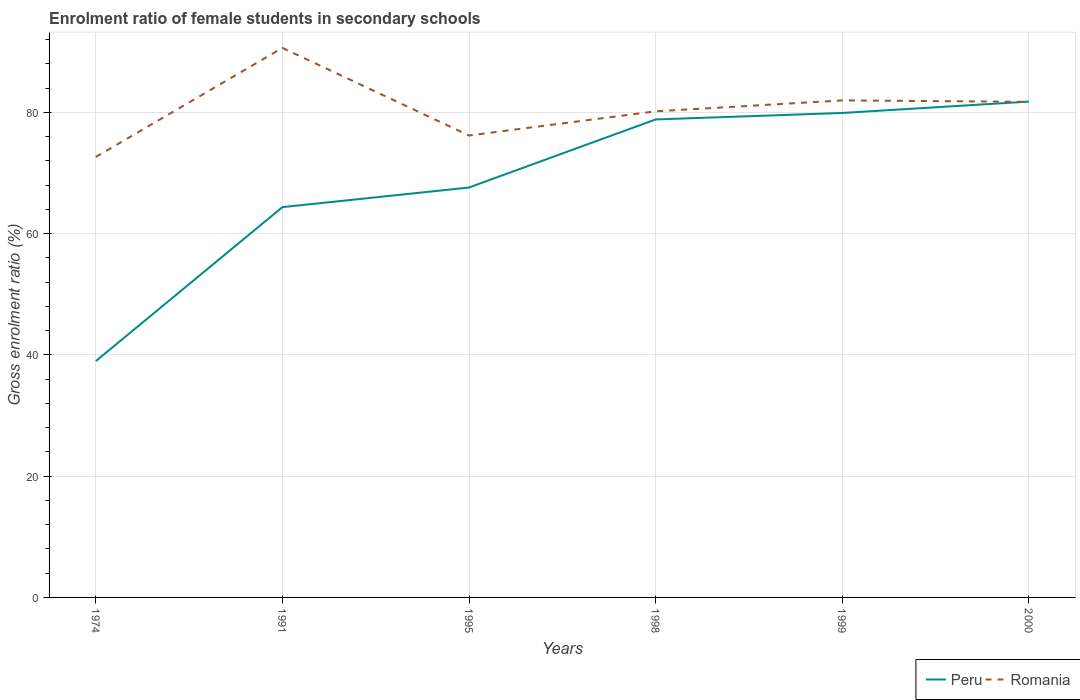How many different coloured lines are there?
Your response must be concise. 2. Is the number of lines equal to the number of legend labels?
Keep it short and to the point. Yes. Across all years, what is the maximum enrolment ratio of female students in secondary schools in Peru?
Give a very brief answer. 38.97. In which year was the enrolment ratio of female students in secondary schools in Romania maximum?
Give a very brief answer. 1974. What is the total enrolment ratio of female students in secondary schools in Peru in the graph?
Give a very brief answer. -1.87. What is the difference between the highest and the second highest enrolment ratio of female students in secondary schools in Romania?
Your answer should be compact. 17.98. Is the enrolment ratio of female students in secondary schools in Peru strictly greater than the enrolment ratio of female students in secondary schools in Romania over the years?
Ensure brevity in your answer.  No. How many years are there in the graph?
Give a very brief answer. 6. Does the graph contain any zero values?
Your answer should be very brief. No. Does the graph contain grids?
Provide a short and direct response. Yes. Where does the legend appear in the graph?
Provide a succinct answer. Bottom right. What is the title of the graph?
Provide a succinct answer. Enrolment ratio of female students in secondary schools. What is the Gross enrolment ratio (%) in Peru in 1974?
Keep it short and to the point. 38.97. What is the Gross enrolment ratio (%) of Romania in 1974?
Your answer should be very brief. 72.65. What is the Gross enrolment ratio (%) of Peru in 1991?
Your answer should be compact. 64.37. What is the Gross enrolment ratio (%) of Romania in 1991?
Your response must be concise. 90.63. What is the Gross enrolment ratio (%) in Peru in 1995?
Your answer should be very brief. 67.6. What is the Gross enrolment ratio (%) in Romania in 1995?
Your answer should be very brief. 76.18. What is the Gross enrolment ratio (%) in Peru in 1998?
Keep it short and to the point. 78.83. What is the Gross enrolment ratio (%) of Romania in 1998?
Your answer should be very brief. 80.17. What is the Gross enrolment ratio (%) in Peru in 1999?
Keep it short and to the point. 79.9. What is the Gross enrolment ratio (%) in Romania in 1999?
Provide a short and direct response. 81.97. What is the Gross enrolment ratio (%) of Peru in 2000?
Make the answer very short. 81.77. What is the Gross enrolment ratio (%) of Romania in 2000?
Your response must be concise. 81.74. Across all years, what is the maximum Gross enrolment ratio (%) of Peru?
Give a very brief answer. 81.77. Across all years, what is the maximum Gross enrolment ratio (%) of Romania?
Ensure brevity in your answer.  90.63. Across all years, what is the minimum Gross enrolment ratio (%) of Peru?
Your answer should be compact. 38.97. Across all years, what is the minimum Gross enrolment ratio (%) of Romania?
Your answer should be very brief. 72.65. What is the total Gross enrolment ratio (%) in Peru in the graph?
Ensure brevity in your answer.  411.43. What is the total Gross enrolment ratio (%) in Romania in the graph?
Keep it short and to the point. 483.33. What is the difference between the Gross enrolment ratio (%) in Peru in 1974 and that in 1991?
Keep it short and to the point. -25.4. What is the difference between the Gross enrolment ratio (%) of Romania in 1974 and that in 1991?
Provide a succinct answer. -17.98. What is the difference between the Gross enrolment ratio (%) of Peru in 1974 and that in 1995?
Offer a terse response. -28.63. What is the difference between the Gross enrolment ratio (%) in Romania in 1974 and that in 1995?
Your answer should be very brief. -3.54. What is the difference between the Gross enrolment ratio (%) in Peru in 1974 and that in 1998?
Your answer should be compact. -39.86. What is the difference between the Gross enrolment ratio (%) in Romania in 1974 and that in 1998?
Your response must be concise. -7.52. What is the difference between the Gross enrolment ratio (%) in Peru in 1974 and that in 1999?
Provide a succinct answer. -40.93. What is the difference between the Gross enrolment ratio (%) of Romania in 1974 and that in 1999?
Your response must be concise. -9.32. What is the difference between the Gross enrolment ratio (%) of Peru in 1974 and that in 2000?
Your response must be concise. -42.8. What is the difference between the Gross enrolment ratio (%) of Romania in 1974 and that in 2000?
Your response must be concise. -9.09. What is the difference between the Gross enrolment ratio (%) in Peru in 1991 and that in 1995?
Give a very brief answer. -3.24. What is the difference between the Gross enrolment ratio (%) in Romania in 1991 and that in 1995?
Your answer should be very brief. 14.44. What is the difference between the Gross enrolment ratio (%) in Peru in 1991 and that in 1998?
Make the answer very short. -14.46. What is the difference between the Gross enrolment ratio (%) of Romania in 1991 and that in 1998?
Provide a succinct answer. 10.46. What is the difference between the Gross enrolment ratio (%) in Peru in 1991 and that in 1999?
Provide a succinct answer. -15.53. What is the difference between the Gross enrolment ratio (%) of Romania in 1991 and that in 1999?
Keep it short and to the point. 8.66. What is the difference between the Gross enrolment ratio (%) in Peru in 1991 and that in 2000?
Your response must be concise. -17.4. What is the difference between the Gross enrolment ratio (%) of Romania in 1991 and that in 2000?
Provide a short and direct response. 8.89. What is the difference between the Gross enrolment ratio (%) in Peru in 1995 and that in 1998?
Give a very brief answer. -11.22. What is the difference between the Gross enrolment ratio (%) in Romania in 1995 and that in 1998?
Keep it short and to the point. -3.99. What is the difference between the Gross enrolment ratio (%) of Peru in 1995 and that in 1999?
Ensure brevity in your answer.  -12.29. What is the difference between the Gross enrolment ratio (%) of Romania in 1995 and that in 1999?
Your response must be concise. -5.79. What is the difference between the Gross enrolment ratio (%) in Peru in 1995 and that in 2000?
Your answer should be compact. -14.17. What is the difference between the Gross enrolment ratio (%) of Romania in 1995 and that in 2000?
Your answer should be very brief. -5.55. What is the difference between the Gross enrolment ratio (%) of Peru in 1998 and that in 1999?
Your answer should be compact. -1.07. What is the difference between the Gross enrolment ratio (%) in Romania in 1998 and that in 1999?
Your answer should be compact. -1.8. What is the difference between the Gross enrolment ratio (%) in Peru in 1998 and that in 2000?
Your answer should be compact. -2.94. What is the difference between the Gross enrolment ratio (%) in Romania in 1998 and that in 2000?
Provide a short and direct response. -1.57. What is the difference between the Gross enrolment ratio (%) in Peru in 1999 and that in 2000?
Give a very brief answer. -1.87. What is the difference between the Gross enrolment ratio (%) of Romania in 1999 and that in 2000?
Your answer should be very brief. 0.23. What is the difference between the Gross enrolment ratio (%) of Peru in 1974 and the Gross enrolment ratio (%) of Romania in 1991?
Make the answer very short. -51.66. What is the difference between the Gross enrolment ratio (%) in Peru in 1974 and the Gross enrolment ratio (%) in Romania in 1995?
Ensure brevity in your answer.  -37.21. What is the difference between the Gross enrolment ratio (%) in Peru in 1974 and the Gross enrolment ratio (%) in Romania in 1998?
Keep it short and to the point. -41.2. What is the difference between the Gross enrolment ratio (%) in Peru in 1974 and the Gross enrolment ratio (%) in Romania in 1999?
Your answer should be very brief. -43. What is the difference between the Gross enrolment ratio (%) in Peru in 1974 and the Gross enrolment ratio (%) in Romania in 2000?
Offer a very short reply. -42.77. What is the difference between the Gross enrolment ratio (%) in Peru in 1991 and the Gross enrolment ratio (%) in Romania in 1995?
Offer a terse response. -11.82. What is the difference between the Gross enrolment ratio (%) in Peru in 1991 and the Gross enrolment ratio (%) in Romania in 1998?
Provide a short and direct response. -15.8. What is the difference between the Gross enrolment ratio (%) of Peru in 1991 and the Gross enrolment ratio (%) of Romania in 1999?
Make the answer very short. -17.6. What is the difference between the Gross enrolment ratio (%) of Peru in 1991 and the Gross enrolment ratio (%) of Romania in 2000?
Your answer should be compact. -17.37. What is the difference between the Gross enrolment ratio (%) of Peru in 1995 and the Gross enrolment ratio (%) of Romania in 1998?
Make the answer very short. -12.57. What is the difference between the Gross enrolment ratio (%) of Peru in 1995 and the Gross enrolment ratio (%) of Romania in 1999?
Your answer should be compact. -14.37. What is the difference between the Gross enrolment ratio (%) in Peru in 1995 and the Gross enrolment ratio (%) in Romania in 2000?
Provide a short and direct response. -14.13. What is the difference between the Gross enrolment ratio (%) in Peru in 1998 and the Gross enrolment ratio (%) in Romania in 1999?
Make the answer very short. -3.14. What is the difference between the Gross enrolment ratio (%) of Peru in 1998 and the Gross enrolment ratio (%) of Romania in 2000?
Offer a terse response. -2.91. What is the difference between the Gross enrolment ratio (%) in Peru in 1999 and the Gross enrolment ratio (%) in Romania in 2000?
Your answer should be compact. -1.84. What is the average Gross enrolment ratio (%) in Peru per year?
Give a very brief answer. 68.57. What is the average Gross enrolment ratio (%) of Romania per year?
Your answer should be compact. 80.56. In the year 1974, what is the difference between the Gross enrolment ratio (%) in Peru and Gross enrolment ratio (%) in Romania?
Keep it short and to the point. -33.68. In the year 1991, what is the difference between the Gross enrolment ratio (%) of Peru and Gross enrolment ratio (%) of Romania?
Your response must be concise. -26.26. In the year 1995, what is the difference between the Gross enrolment ratio (%) in Peru and Gross enrolment ratio (%) in Romania?
Provide a succinct answer. -8.58. In the year 1998, what is the difference between the Gross enrolment ratio (%) in Peru and Gross enrolment ratio (%) in Romania?
Provide a succinct answer. -1.34. In the year 1999, what is the difference between the Gross enrolment ratio (%) of Peru and Gross enrolment ratio (%) of Romania?
Provide a short and direct response. -2.07. In the year 2000, what is the difference between the Gross enrolment ratio (%) in Peru and Gross enrolment ratio (%) in Romania?
Ensure brevity in your answer.  0.04. What is the ratio of the Gross enrolment ratio (%) of Peru in 1974 to that in 1991?
Your answer should be very brief. 0.61. What is the ratio of the Gross enrolment ratio (%) of Romania in 1974 to that in 1991?
Offer a very short reply. 0.8. What is the ratio of the Gross enrolment ratio (%) in Peru in 1974 to that in 1995?
Ensure brevity in your answer.  0.58. What is the ratio of the Gross enrolment ratio (%) in Romania in 1974 to that in 1995?
Keep it short and to the point. 0.95. What is the ratio of the Gross enrolment ratio (%) in Peru in 1974 to that in 1998?
Offer a terse response. 0.49. What is the ratio of the Gross enrolment ratio (%) of Romania in 1974 to that in 1998?
Give a very brief answer. 0.91. What is the ratio of the Gross enrolment ratio (%) of Peru in 1974 to that in 1999?
Offer a very short reply. 0.49. What is the ratio of the Gross enrolment ratio (%) of Romania in 1974 to that in 1999?
Your answer should be compact. 0.89. What is the ratio of the Gross enrolment ratio (%) in Peru in 1974 to that in 2000?
Provide a short and direct response. 0.48. What is the ratio of the Gross enrolment ratio (%) in Romania in 1974 to that in 2000?
Give a very brief answer. 0.89. What is the ratio of the Gross enrolment ratio (%) of Peru in 1991 to that in 1995?
Your answer should be compact. 0.95. What is the ratio of the Gross enrolment ratio (%) of Romania in 1991 to that in 1995?
Give a very brief answer. 1.19. What is the ratio of the Gross enrolment ratio (%) of Peru in 1991 to that in 1998?
Your answer should be compact. 0.82. What is the ratio of the Gross enrolment ratio (%) in Romania in 1991 to that in 1998?
Your answer should be very brief. 1.13. What is the ratio of the Gross enrolment ratio (%) of Peru in 1991 to that in 1999?
Your answer should be very brief. 0.81. What is the ratio of the Gross enrolment ratio (%) of Romania in 1991 to that in 1999?
Your answer should be very brief. 1.11. What is the ratio of the Gross enrolment ratio (%) in Peru in 1991 to that in 2000?
Provide a short and direct response. 0.79. What is the ratio of the Gross enrolment ratio (%) of Romania in 1991 to that in 2000?
Keep it short and to the point. 1.11. What is the ratio of the Gross enrolment ratio (%) in Peru in 1995 to that in 1998?
Ensure brevity in your answer.  0.86. What is the ratio of the Gross enrolment ratio (%) of Romania in 1995 to that in 1998?
Keep it short and to the point. 0.95. What is the ratio of the Gross enrolment ratio (%) in Peru in 1995 to that in 1999?
Your response must be concise. 0.85. What is the ratio of the Gross enrolment ratio (%) of Romania in 1995 to that in 1999?
Make the answer very short. 0.93. What is the ratio of the Gross enrolment ratio (%) of Peru in 1995 to that in 2000?
Keep it short and to the point. 0.83. What is the ratio of the Gross enrolment ratio (%) of Romania in 1995 to that in 2000?
Provide a short and direct response. 0.93. What is the ratio of the Gross enrolment ratio (%) in Peru in 1998 to that in 1999?
Make the answer very short. 0.99. What is the ratio of the Gross enrolment ratio (%) in Romania in 1998 to that in 2000?
Your answer should be very brief. 0.98. What is the ratio of the Gross enrolment ratio (%) of Peru in 1999 to that in 2000?
Ensure brevity in your answer.  0.98. What is the difference between the highest and the second highest Gross enrolment ratio (%) in Peru?
Your answer should be compact. 1.87. What is the difference between the highest and the second highest Gross enrolment ratio (%) of Romania?
Your response must be concise. 8.66. What is the difference between the highest and the lowest Gross enrolment ratio (%) of Peru?
Give a very brief answer. 42.8. What is the difference between the highest and the lowest Gross enrolment ratio (%) of Romania?
Offer a very short reply. 17.98. 